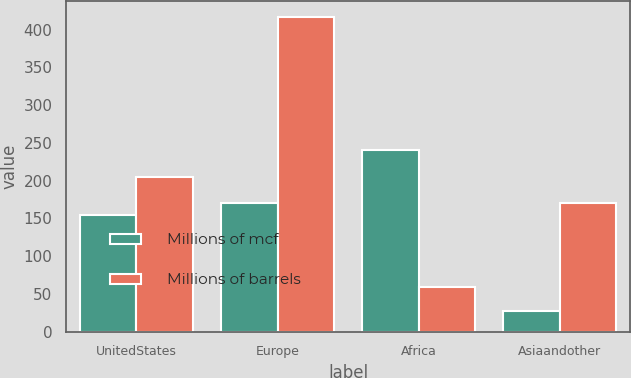<chart> <loc_0><loc_0><loc_500><loc_500><stacked_bar_chart><ecel><fcel>UnitedStates<fcel>Europe<fcel>Africa<fcel>Asiaandother<nl><fcel>Millions of mcf<fcel>154<fcel>171<fcel>241<fcel>27<nl><fcel>Millions of barrels<fcel>205<fcel>417<fcel>59<fcel>171<nl></chart> 